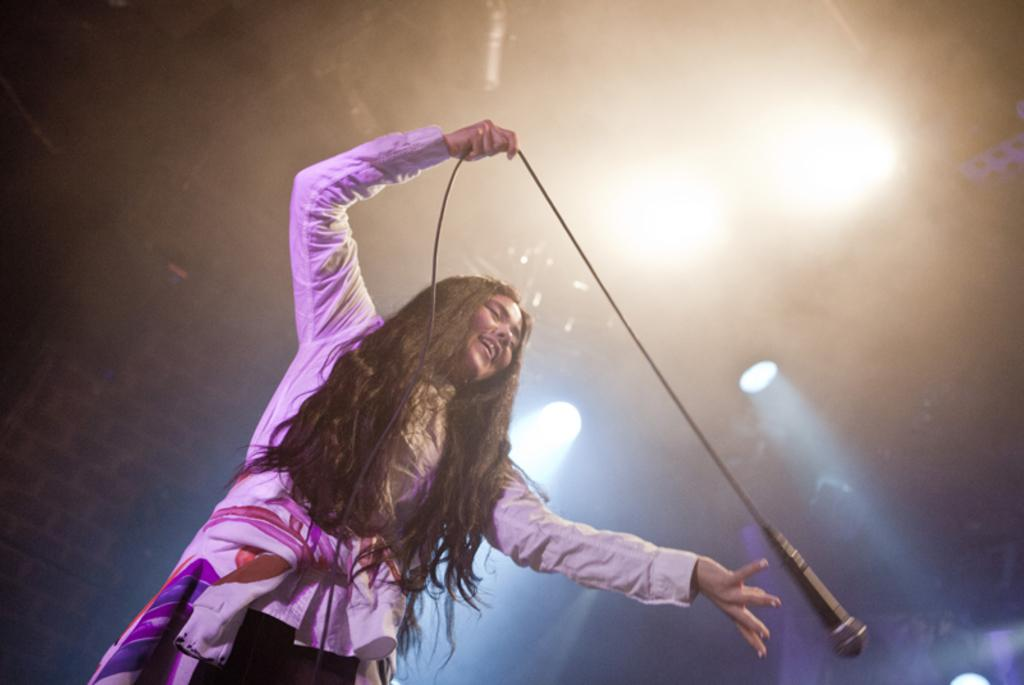What is the woman in the image doing? The woman is standing in the image. What is the woman holding in the image? The woman is holding a microphone. What can be seen attached to the ceiling in the image? There are lights attached to the ceiling in the image. What is the woman's belief about science in the image? There is no information about the woman's beliefs or opinions about science in the image. 